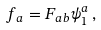<formula> <loc_0><loc_0><loc_500><loc_500>f _ { a } = F _ { a b } \psi ^ { a } _ { 1 } \, ,</formula> 